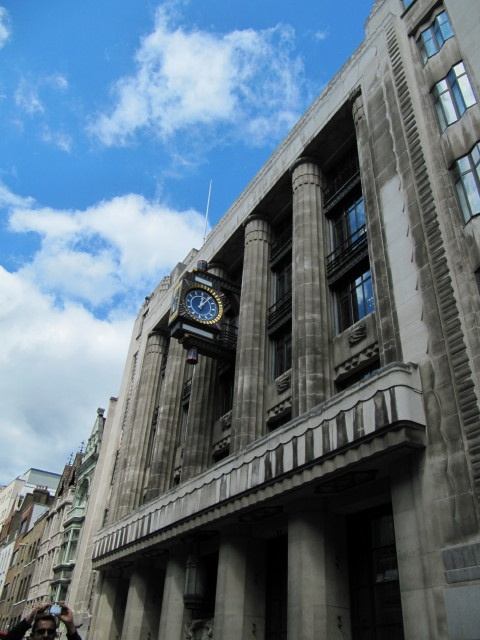Describe the objects in this image and their specific colors. I can see people in gray, black, and darkgray tones and clock in gray, black, darkblue, and navy tones in this image. 